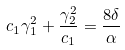Convert formula to latex. <formula><loc_0><loc_0><loc_500><loc_500>c _ { 1 } \gamma _ { 1 } ^ { 2 } + \frac { \gamma _ { 2 } ^ { 2 } } { c _ { 1 } } = \frac { 8 \delta } { \alpha }</formula> 